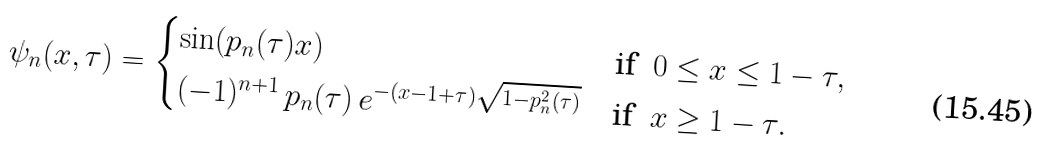<formula> <loc_0><loc_0><loc_500><loc_500>\psi _ { n } ( x , \tau ) = \begin{cases} \sin ( p _ { n } ( \tau ) x ) & \text {if \ } 0 \leq x \leq 1 - \tau , \\ ( - 1 ) ^ { n + 1 } \, p _ { n } ( \tau ) \, e ^ { - ( x - 1 + \tau ) \sqrt { 1 - p _ { n } ^ { 2 } ( \tau ) } } & \text {if \ } x \geq 1 - \tau . \end{cases}</formula> 